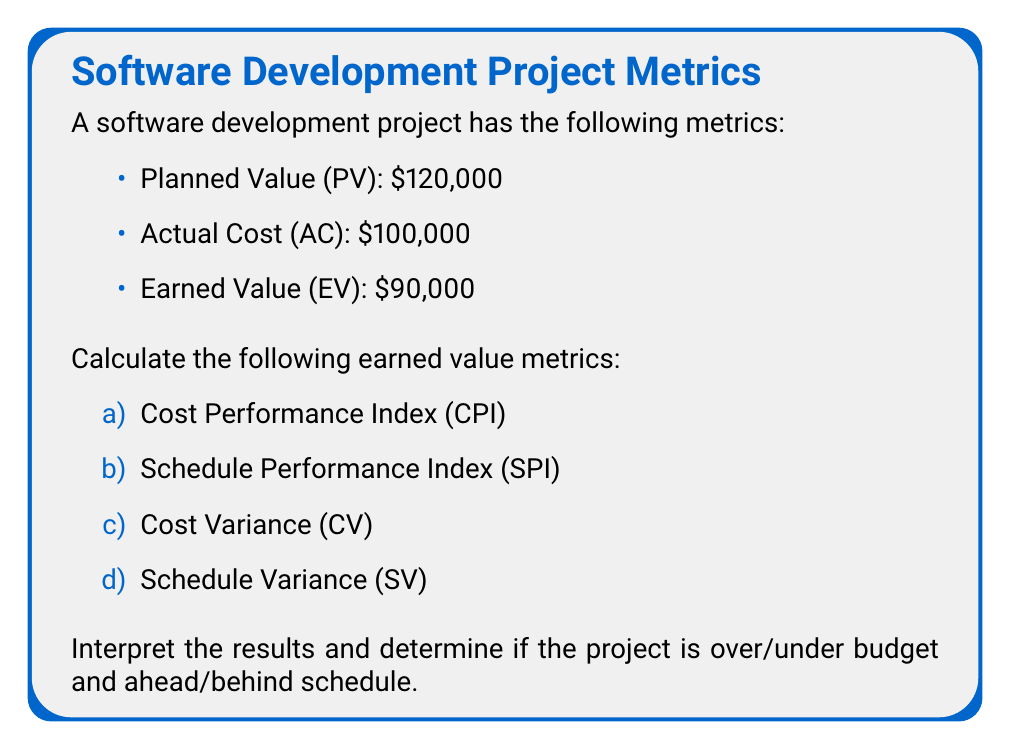Give your solution to this math problem. Let's calculate each metric step-by-step:

a) Cost Performance Index (CPI):
CPI is calculated as EV divided by AC.
$$ CPI = \frac{EV}{AC} = \frac{90,000}{100,000} = 0.9 $$

b) Schedule Performance Index (SPI):
SPI is calculated as EV divided by PV.
$$ SPI = \frac{EV}{PV} = \frac{90,000}{120,000} = 0.75 $$

c) Cost Variance (CV):
CV is calculated as EV minus AC.
$$ CV = EV - AC = 90,000 - 100,000 = -10,000 $$

d) Schedule Variance (SV):
SV is calculated as EV minus PV.
$$ SV = EV - PV = 90,000 - 120,000 = -30,000 $$

Interpretation:
1. CPI = 0.9 (less than 1): The project is over budget. For every $1 spent, we're earning $0.90 in value.
2. SPI = 0.75 (less than 1): The project is behind schedule. We've completed 75% of the work we planned to complete by this point.
3. CV = -$10,000 (negative): The project is over budget by $10,000.
4. SV = -$30,000 (negative): The project is behind schedule, with $30,000 worth of work not completed as planned.

In summary, the project is both over budget and behind schedule.
Answer: CPI = 0.9, SPI = 0.75, CV = -$10,000, SV = -$30,000. Project is over budget and behind schedule. 